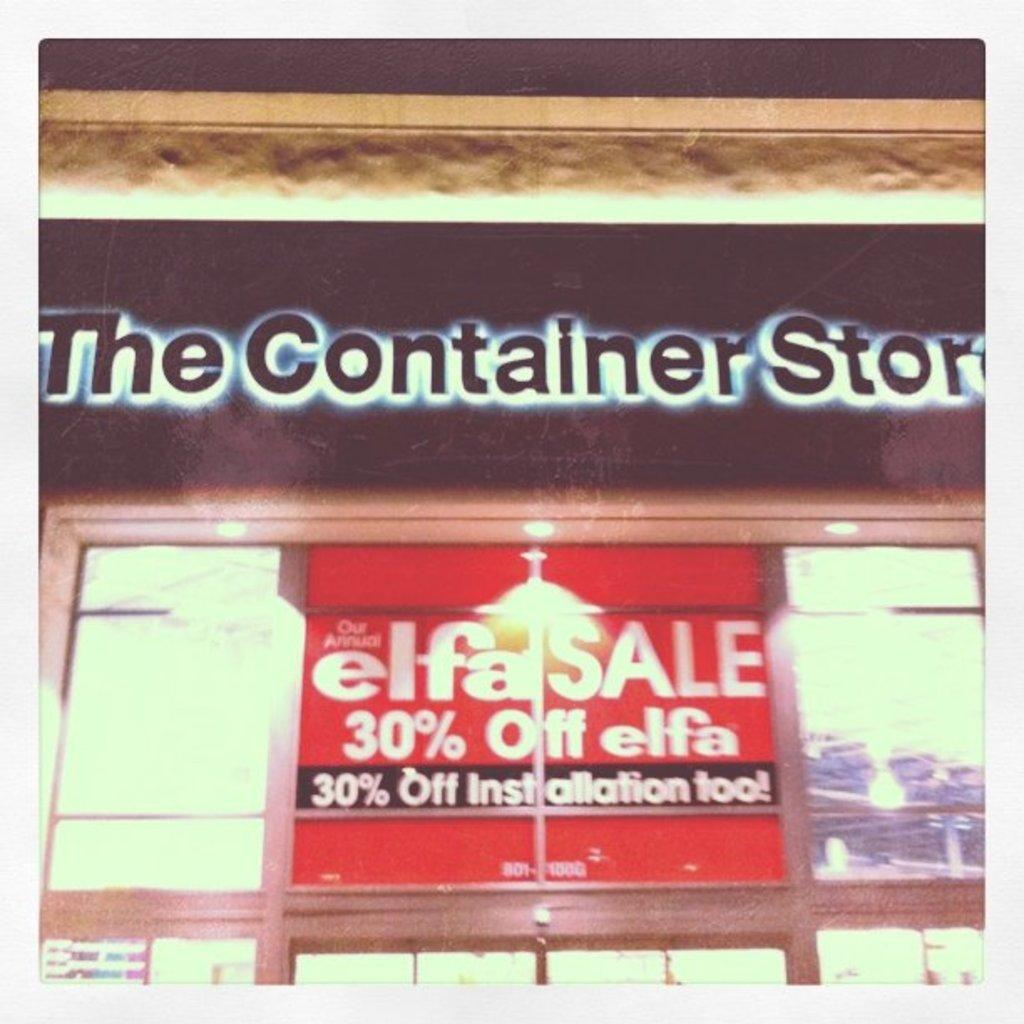Provide a one-sentence caption for the provided image. The Container Store is having an Elfa Sale with 30% off installation. 